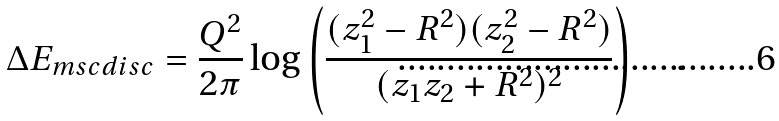<formula> <loc_0><loc_0><loc_500><loc_500>\Delta E _ { m s c d i s c } = \frac { Q ^ { 2 } } { 2 \pi } \log \left ( \frac { ( z _ { 1 } ^ { 2 } - R ^ { 2 } ) ( z _ { 2 } ^ { 2 } - R ^ { 2 } ) } { ( z _ { 1 } z _ { 2 } + R ^ { 2 } ) ^ { 2 } } \right ) \quad .</formula> 